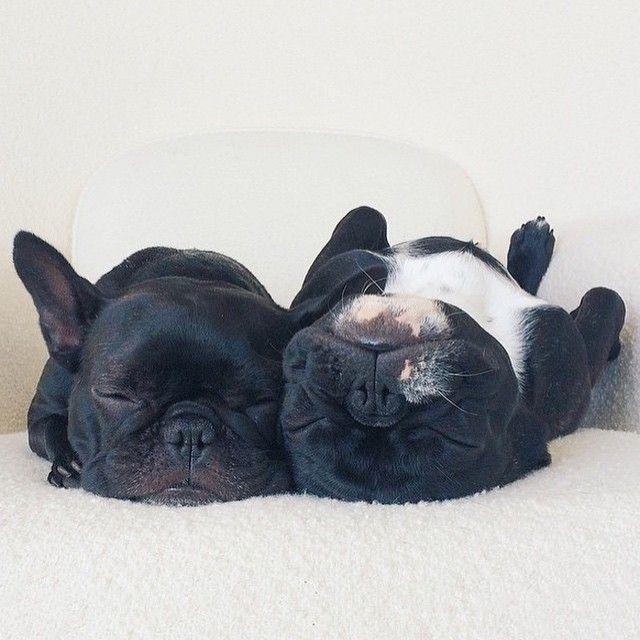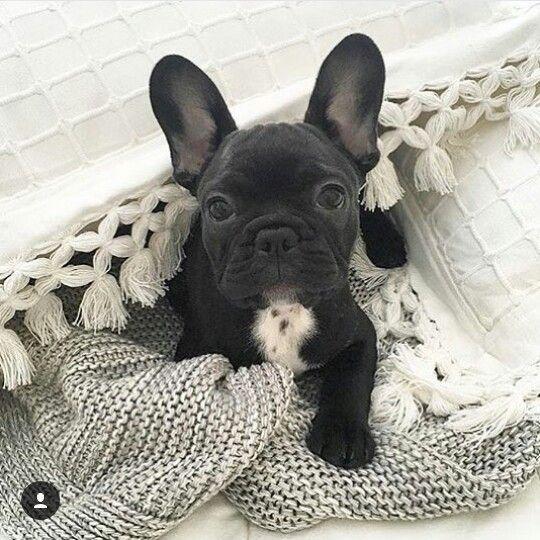The first image is the image on the left, the second image is the image on the right. Evaluate the accuracy of this statement regarding the images: "There are two black French Bulldogs.". Is it true? Answer yes or no. No. 